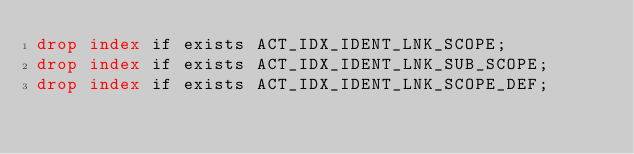<code> <loc_0><loc_0><loc_500><loc_500><_SQL_>drop index if exists ACT_IDX_IDENT_LNK_SCOPE;
drop index if exists ACT_IDX_IDENT_LNK_SUB_SCOPE;
drop index if exists ACT_IDX_IDENT_LNK_SCOPE_DEF;</code> 